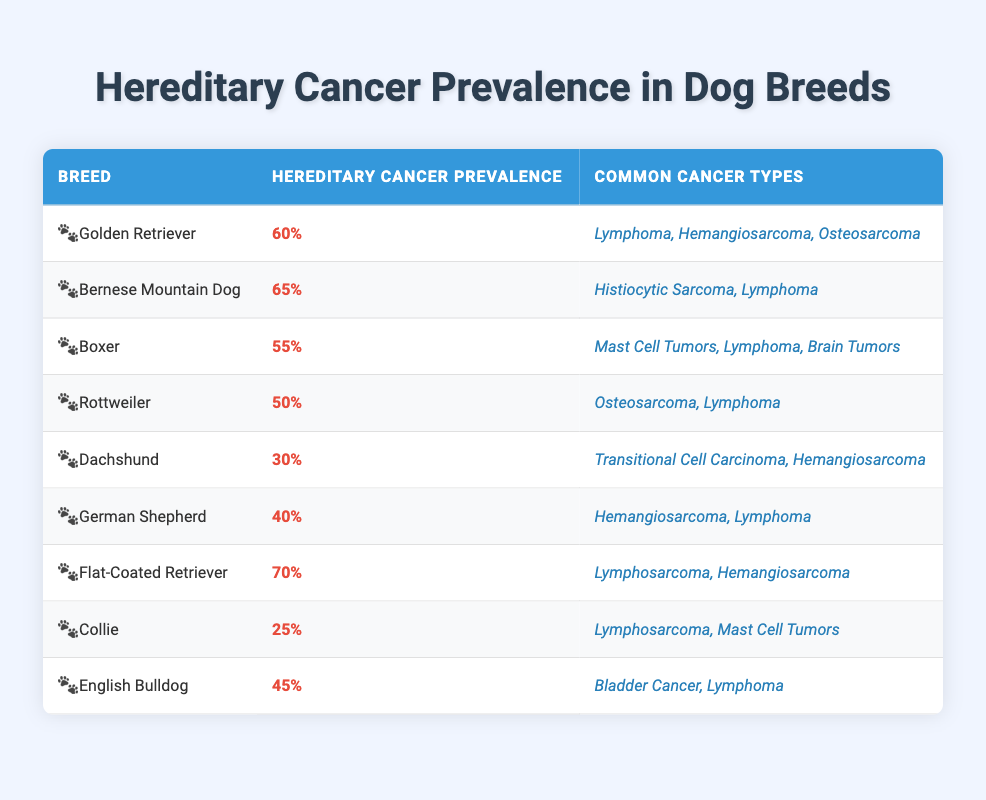What is the hereditary cancer prevalence in Golden Retrievers? The table states that the hereditary cancer prevalence for Golden Retrievers is listed as 60%.
Answer: 60% Which breed has the highest reported hereditary cancer prevalence? According to the table, the breed with the highest hereditary cancer prevalence is the Flat-Coated Retriever at 70%.
Answer: Flat-Coated Retriever What are the common cancer types seen in the Boxer breed? The table lists the common cancer types in Boxers as Mast Cell Tumors, Lymphoma, and Brain Tumors.
Answer: Mast Cell Tumors, Lymphoma, Brain Tumors Which two breeds have a hereditary cancer prevalence of 50% or more? Based on the table, the breeds with a hereditary cancer prevalence of 50% or more are the Bernese Mountain Dog (65%) and the Flat-Coated Retriever (70%).
Answer: Bernese Mountain Dog, Flat-Coated Retriever How many breeds have a hereditary cancer prevalence of less than 40%? The table shows that there are two breeds with a prevalence of less than 40%: Dachshund (30%) and Collie (25%).
Answer: 2 Is it true that Rottweilers have a higher prevalence than German Shepherds? The table indicates that Rottweilers have a prevalence of 50% while German Shepherds have a prevalence of 40%, thus Rottweilers do have a higher prevalence.
Answer: Yes What is the average hereditary cancer prevalence across all listed breeds? To find the average, sum all the prevalences (60 + 65 + 55 + 50 + 30 + 40 + 70 + 25 + 45 = 440) and divide by the number of breeds (9), which results in an average of approximately 48.89%.
Answer: 48.89% How many breeds are associated with Lymphoma as a cancer type? From the table, the breeds associated with Lymphoma are Golden Retriever, Bernese Mountain Dog, Boxer, Rottweiler, German Shepherd, Flat-Coated Retriever, and English Bulldog, totaling 7 breeds.
Answer: 7 Which breed has the lowest prevalence of hereditary cancer? The table shows that Collies have the lowest hereditary cancer prevalence at 25%.
Answer: Collie What is the difference in hereditary cancer prevalence between the Flat-Coated Retriever and the English Bulldog? The Flat-Coated Retriever has a prevalence of 70% and the English Bulldog has a prevalence of 45%. Therefore, the difference is 70% - 45% = 25%.
Answer: 25% 